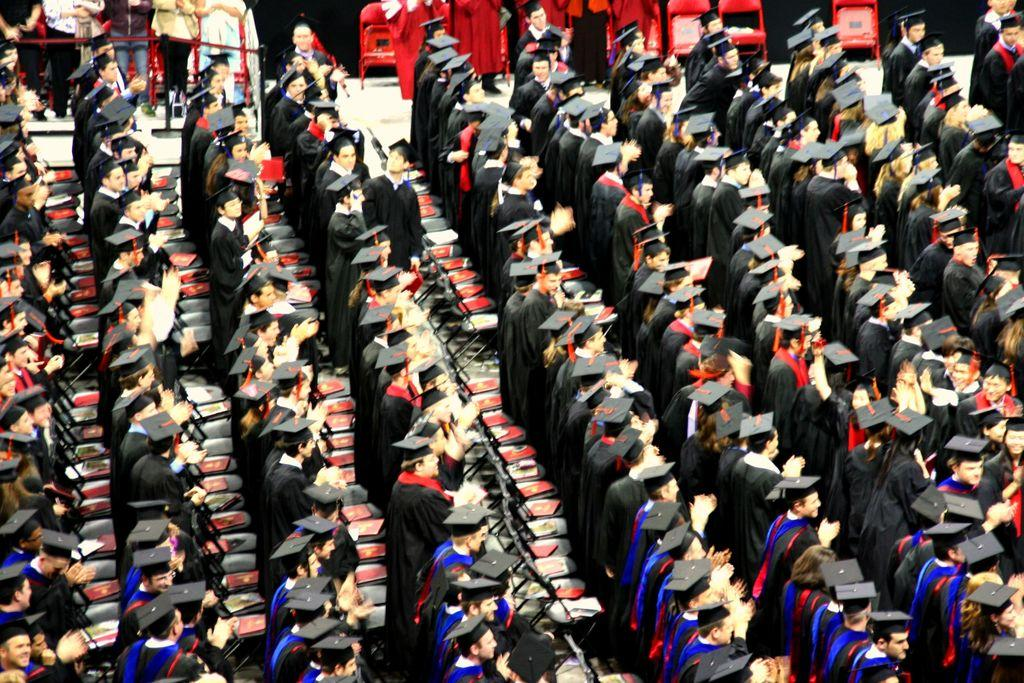How many people are present in the image? There are many people in the image. What are the people wearing in the image? The people are wearing black coats and hats. Can you describe the setting of the image? The setting appears to be a convocation hall. What type of dolls can be seen playing in the bath in the image? There are no dolls or bath present in the image; it features people wearing black coats and hats in a convocation hall. 